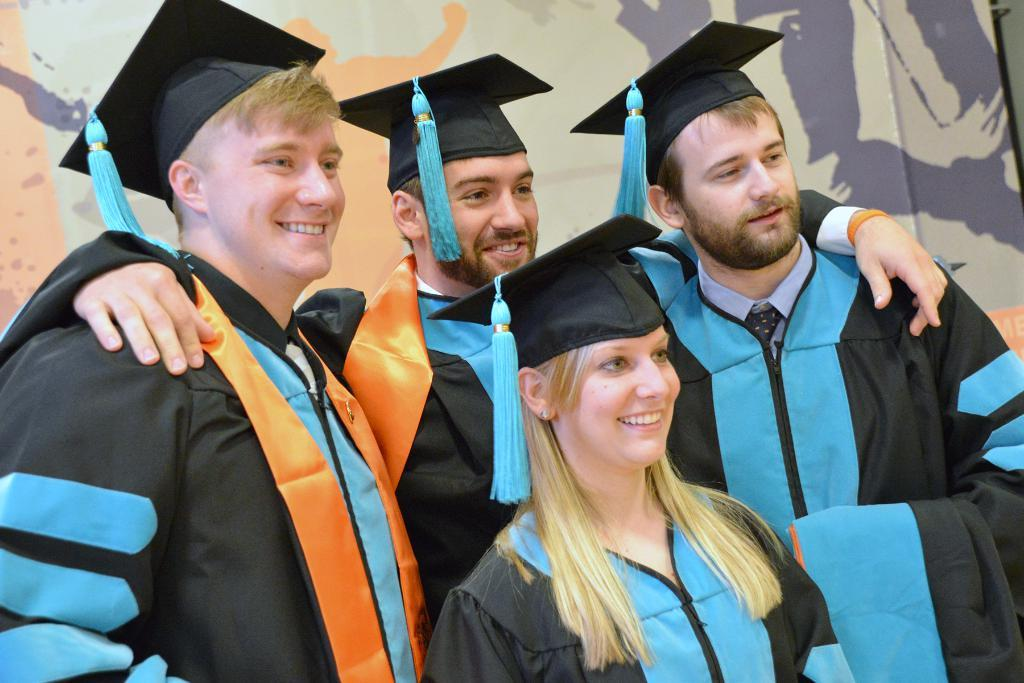How many people are in the image? There are persons in the image, but the exact number is not specified. What are the persons wearing? The persons are wearing clothes and hats. What can be seen in the background of the image? There is a wall in the background of the image. Can you see any bones sticking out of the persons' clothes in the image? There is no mention of bones or any such detail in the image, so we cannot answer this question. 